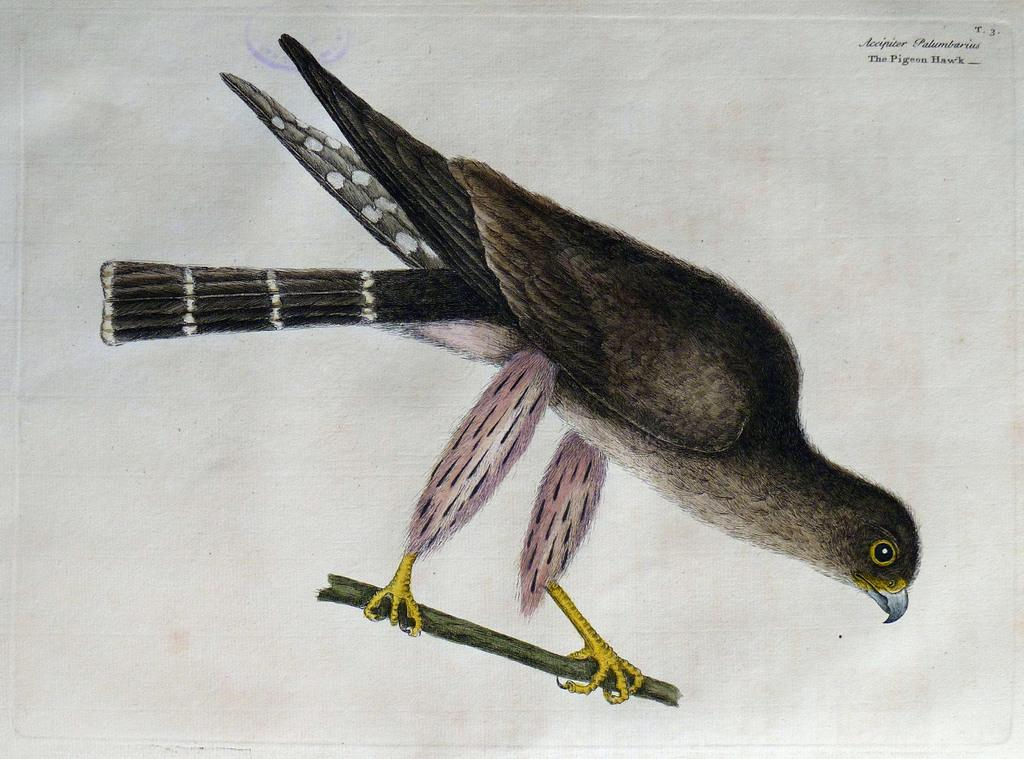What is depicted in the image? There is a drawing of a bird in the image. How is the drawing of the bird displayed? The drawing of the bird is on a stick. What can be found in the top right corner of the image? There is text in the top right corner of the image. How many rabbits can be seen hopping in the image? There are no rabbits present in the image; it features a drawing of a bird on a stick and text in the top right corner. 